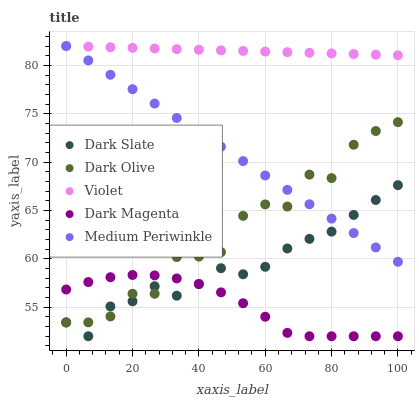Does Dark Magenta have the minimum area under the curve?
Answer yes or no. Yes. Does Violet have the maximum area under the curve?
Answer yes or no. Yes. Does Dark Olive have the minimum area under the curve?
Answer yes or no. No. Does Dark Olive have the maximum area under the curve?
Answer yes or no. No. Is Violet the smoothest?
Answer yes or no. Yes. Is Dark Olive the roughest?
Answer yes or no. Yes. Is Medium Periwinkle the smoothest?
Answer yes or no. No. Is Medium Periwinkle the roughest?
Answer yes or no. No. Does Dark Magenta have the lowest value?
Answer yes or no. Yes. Does Dark Olive have the lowest value?
Answer yes or no. No. Does Violet have the highest value?
Answer yes or no. Yes. Does Dark Olive have the highest value?
Answer yes or no. No. Is Dark Slate less than Violet?
Answer yes or no. Yes. Is Violet greater than Dark Olive?
Answer yes or no. Yes. Does Dark Magenta intersect Dark Slate?
Answer yes or no. Yes. Is Dark Magenta less than Dark Slate?
Answer yes or no. No. Is Dark Magenta greater than Dark Slate?
Answer yes or no. No. Does Dark Slate intersect Violet?
Answer yes or no. No. 